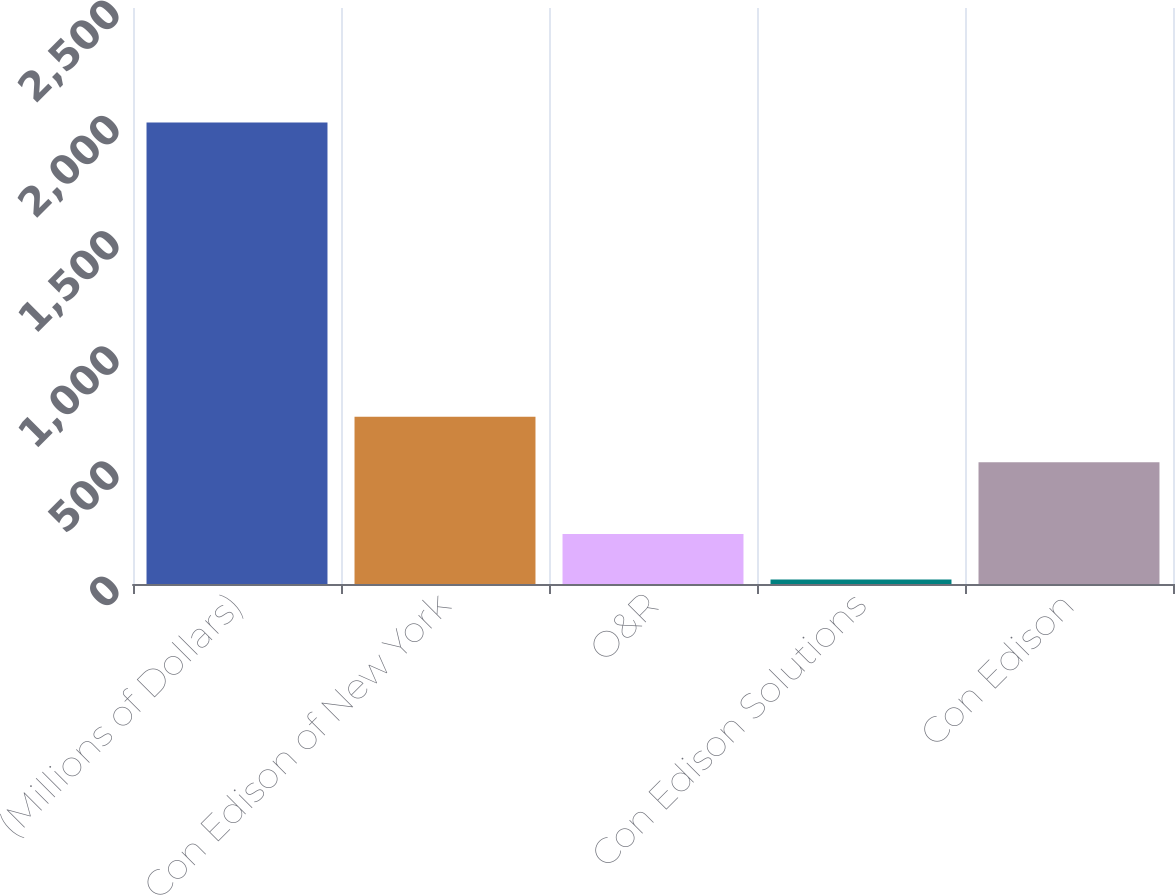Convert chart to OTSL. <chart><loc_0><loc_0><loc_500><loc_500><bar_chart><fcel>(Millions of Dollars)<fcel>Con Edison of New York<fcel>O&R<fcel>Con Edison Solutions<fcel>Con Edison<nl><fcel>2003<fcel>726.4<fcel>217.4<fcel>19<fcel>528<nl></chart> 